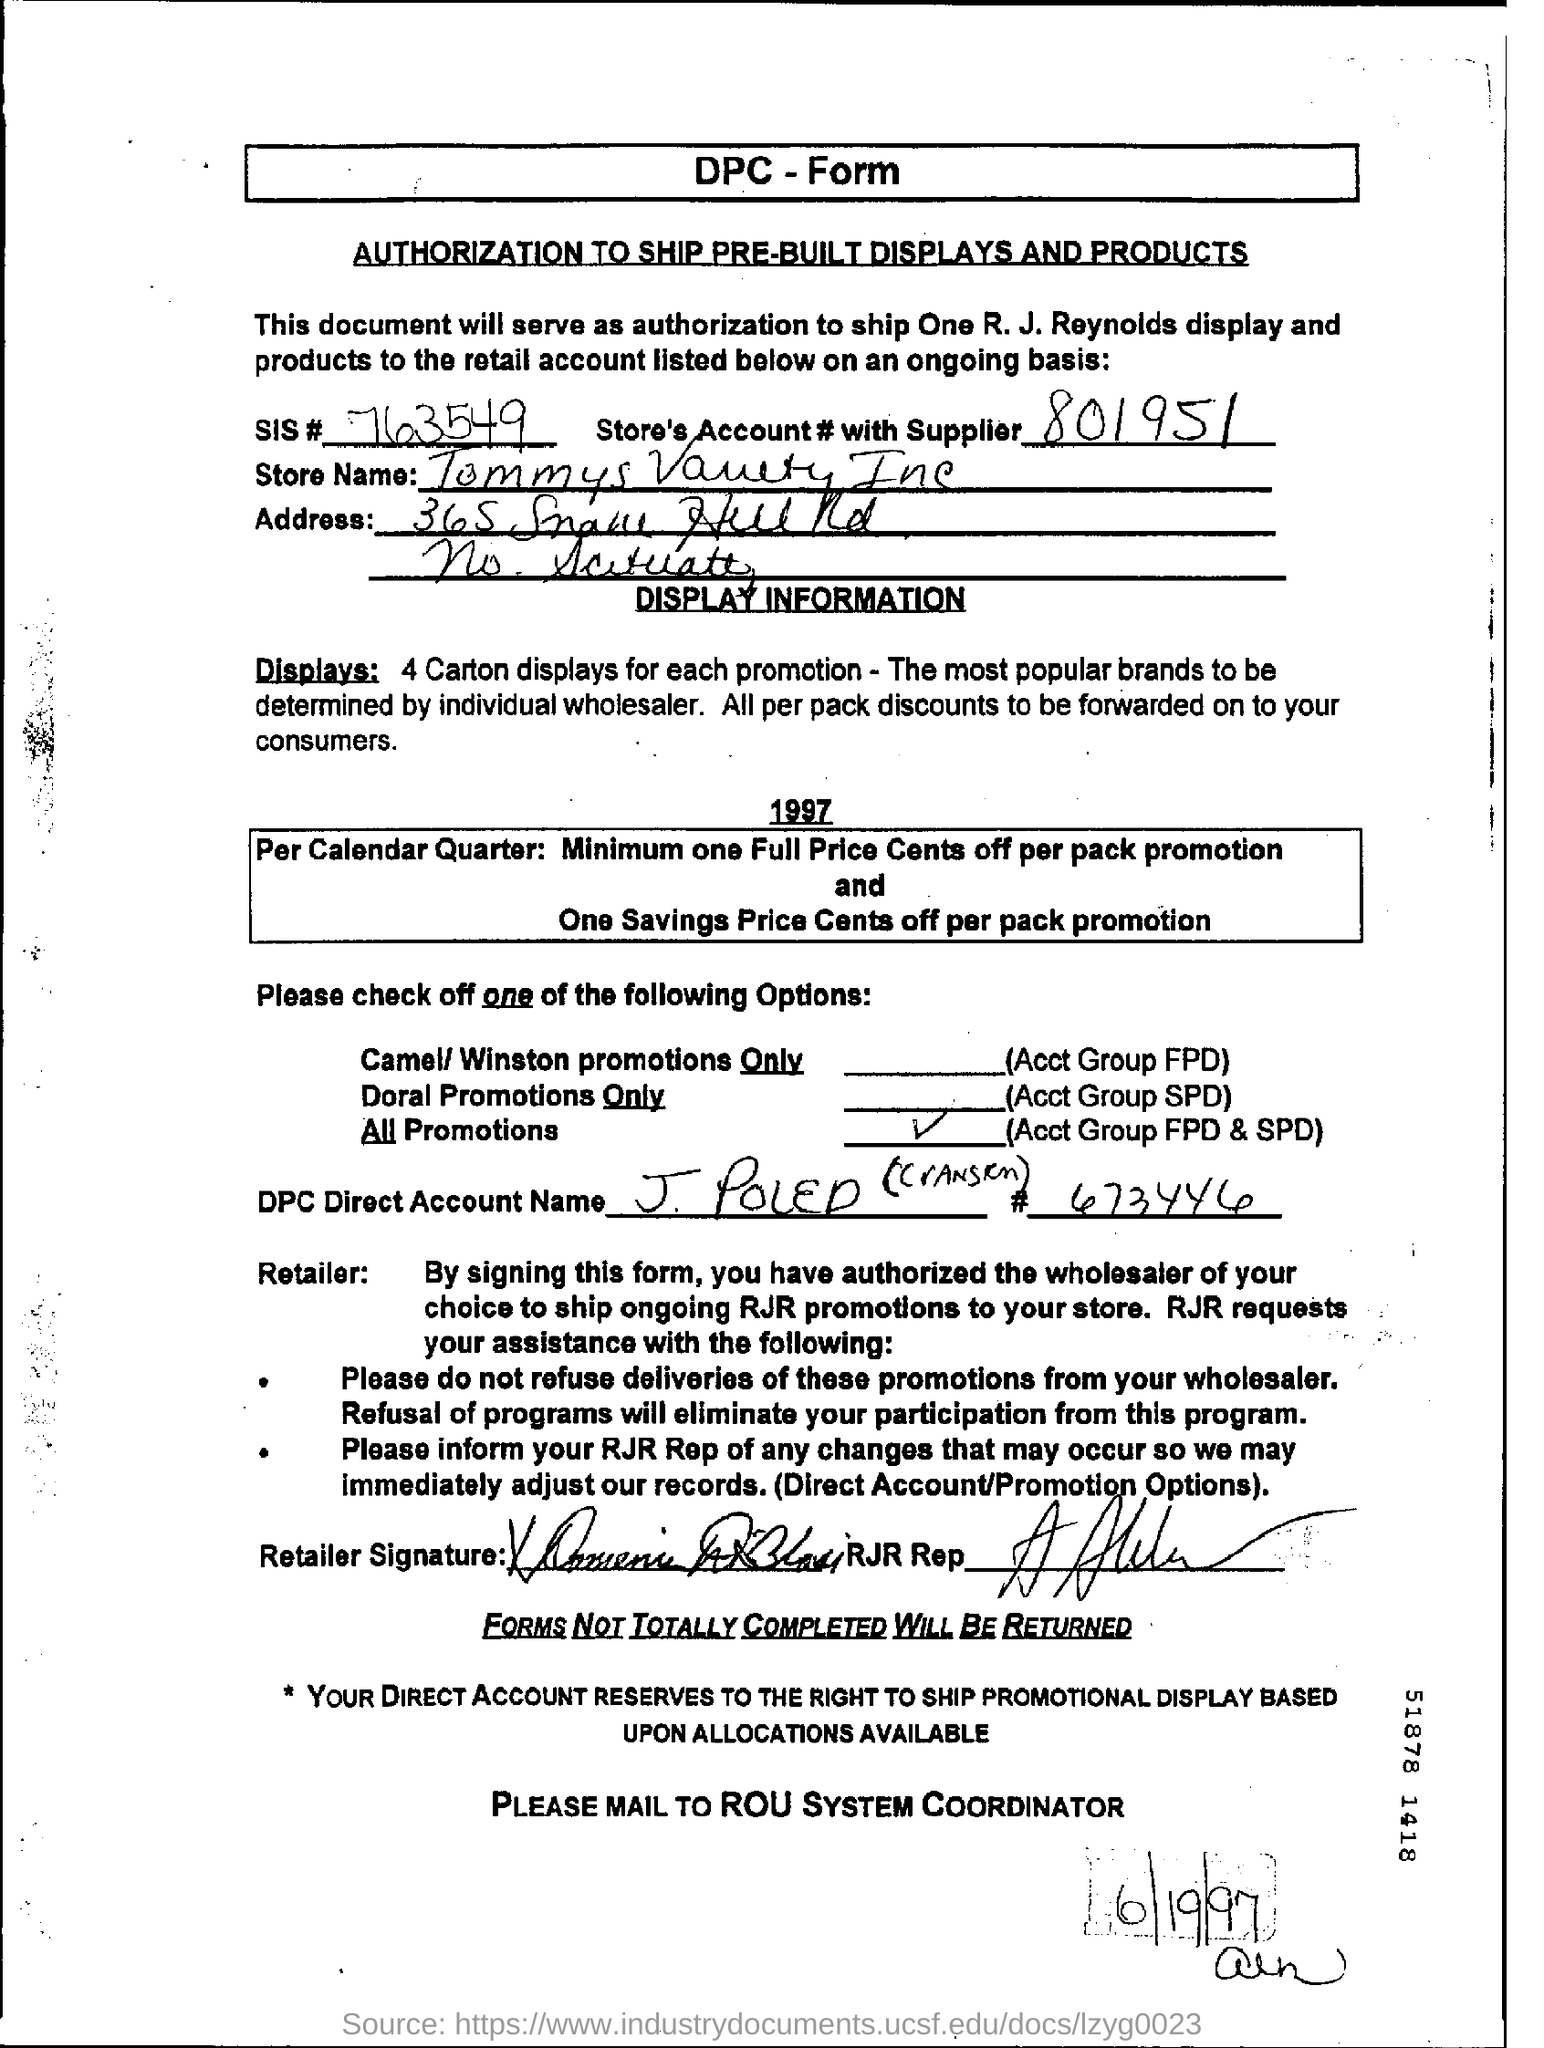What is the name of the form?
Provide a short and direct response. DPC - Form. How many carton displays for each promotion?
Offer a terse response. 4. What is the sis number?
Keep it short and to the point. 763549. What is the store's account number with supplier?
Ensure brevity in your answer.  801951. 